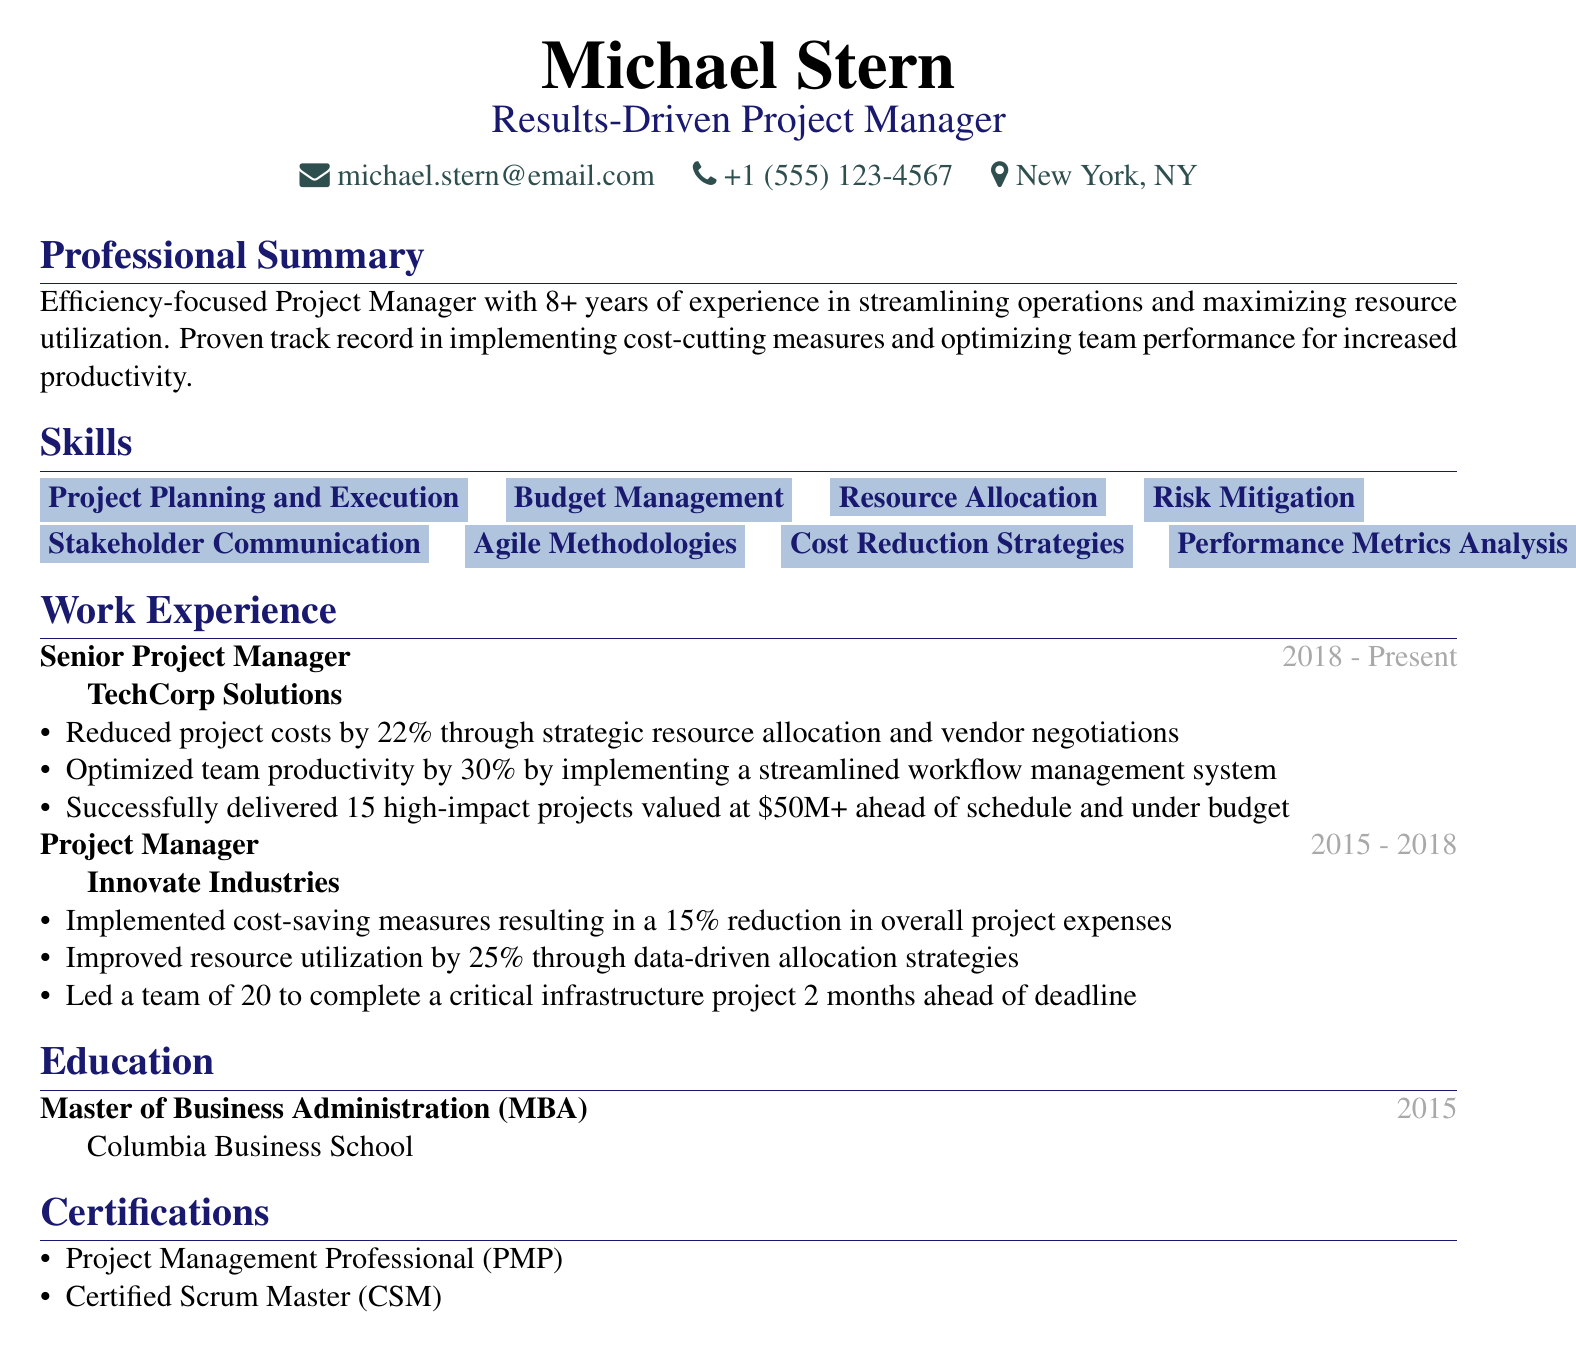what is the name of the project manager? The name is mentioned in the personal information section of the document.
Answer: Michael Stern what is the total percentage reduction in project costs achieved by Michael at TechCorp Solutions? The document lists a specific achievement related to cost reduction in that position.
Answer: 22% how many projects did Michael successfully deliver at TechCorp Solutions? The document specifies the number of high-impact projects delivered at the company.
Answer: 15 what is the degree obtained by Michael Stern? The education section indicates his educational qualifications.
Answer: Master of Business Administration (MBA) how much was the overall reduction in project expenses at Innovate Industries? This figure is detailed in the achievements section under his role as Project Manager.
Answer: 15% how many years of experience does Michael have in project management? The professional summary provides this information directly.
Answer: 8+ which certification is listed first in the certifications section? The order of certifications is specified in the document.
Answer: Project Management Professional (PMP) what percentage increase in resource utilization was achieved at Innovate Industries? The data in the achievements section provides this specific percentage.
Answer: 25% what is the main focus of Michael's professional summary? The professional summary describes his overall approach and expertise.
Answer: Efficiency-focused what role did Michael hold at Innovate Industries? This title is stated in the work experience section.
Answer: Project Manager 